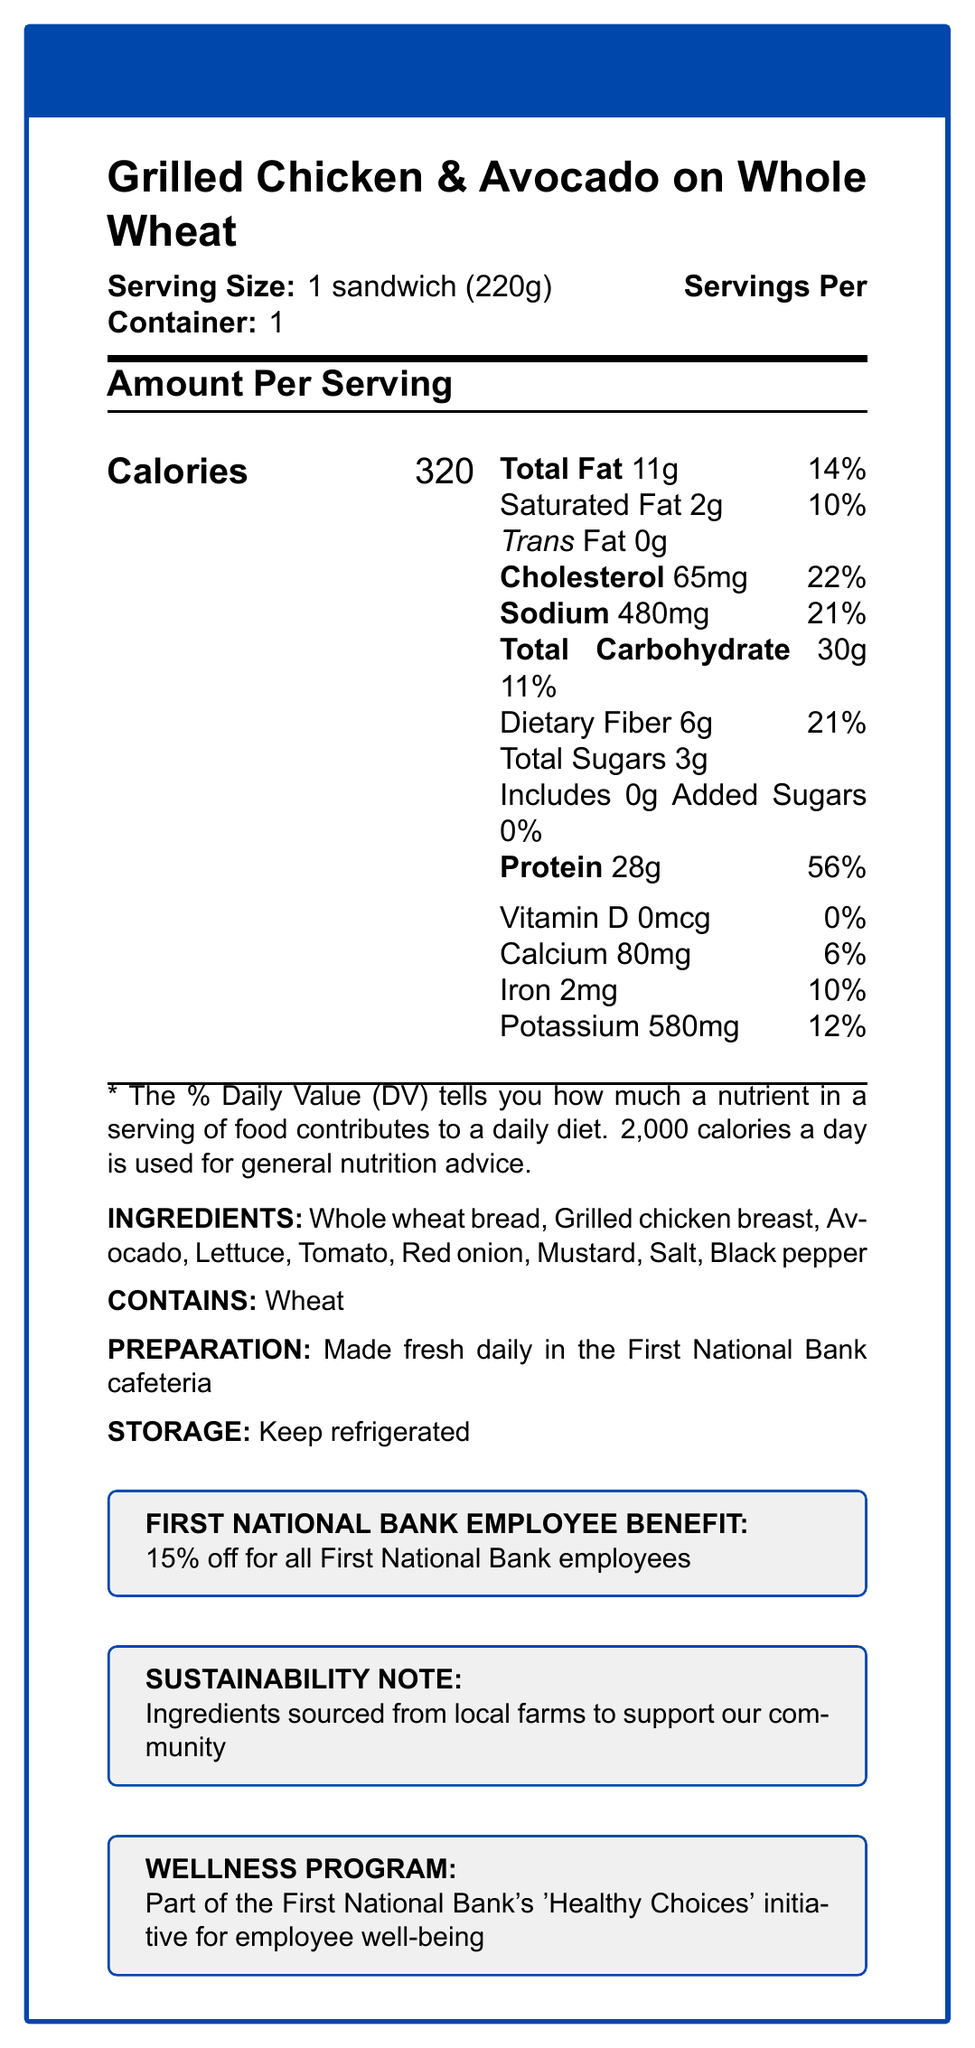what is the serving size of the sandwich? The serving size is listed as "1 sandwich (220g)" in the document.
Answer: 1 sandwich (220g) how many calories are in one serving of the sandwich? The document states that there are 320 calories per serving.
Answer: 320 how much protein does the sandwich provide? The nutrition label specifies that the sandwich contains 28g of protein.
Answer: 28g what percentage of daily value of calcium does the sandwich offer? The document indicates that the sandwich offers 6% of the daily value for calcium.
Answer: 6% how much total fat is in the sandwich? The label shows that the sandwich contains 11g of total fat.
Answer: 11g what ingredients are in the sandwich? The ingredients listed in the document are: Whole wheat bread, Grilled chicken breast, Avocado, Lettuce, Tomato, Red onion, Mustard, Salt, and Black pepper.
Answer: Whole wheat bread, Grilled chicken breast, Avocado, Lettuce, Tomato, Red onion, Mustard, Salt, Black pepper which of the following nutrients is not present in the sandwich? A. Vitamin D B. Iron C. Potassium D. Dietary Fiber The document states that there is 0mcg of Vitamin D, indicating it is not present in the sandwich.
Answer: A what is the correct daily value percentage for sodium in the sandwich? A. 10% B. 20% C. 21% D. 25% The nutrition label shows that the daily value for sodium is 21%.
Answer: C does the sandwich contain any allergens? The document specifies that the sandwich contains wheat.
Answer: Yes describe the benefits offered to First National Bank employees for this sandwich option. The document details multiple benefits: 15% discount for bank employees, part of the "Healthy Choices" initiative, and ingredients sourced from local farms.
Answer: The sandwich offers a 15% discount for all First National Bank employees, is a part of the "Healthy Choices" initiative for employee well-being, and uses ingredients sourced from local farms to support the community. is the sandwich gluten-free? The sandwich contains wheat, which is a source of gluten.
Answer: No what is the main focus of the document? The main focus is the detailed nutrition information and additional benefits and notes for the sandwich.
Answer: The document provides the nutrition facts and additional information about the "Grilled Chicken & Avocado on Whole Wheat" sandwich available in the First National Bank cafeteria, including ingredients, allergen information, employee benefits, and sustainability notes. where is the sandwich made? The preparation section of the document states that the sandwich is made fresh daily in the First National Bank cafeteria.
Answer: First National Bank cafeteria how much cholesterol is in the sandwich? The document indicates that the sandwich contains 65mg of cholesterol.
Answer: 65mg what type of bread is used in the sandwich? The ingredients list specifies that the sandwich uses whole wheat bread.
Answer: Whole wheat bread is this sandwich part of any wellness program? The document mentions that this sandwich is part of the First National Bank's 'Healthy Choices' initiative for employee well-being.
Answer: Yes what is the specific daily value percentage for dietary fiber provided by the sandwich? According to the nutrition label, the sandwich provides 21% of the daily value for dietary fiber.
Answer: 21% are there any added sugars in the sandwich? The document specifies that the sandwich includes 0g of added sugars.
Answer: No how should the sandwich be stored? The storage instructions in the document say to keep the sandwich refrigerated.
Answer: Keep refrigerated what is the vitamin D content of the sandwich? A. 5mcg B. 10mcg C. 0mcg D. 20mcg The document indicates that the vitamin D content is 0mcg.
Answer: C 